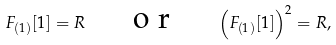<formula> <loc_0><loc_0><loc_500><loc_500>F _ { ( 1 ) } [ 1 ] = R \quad \emph { \emph { o r } } \quad \left ( F _ { ( 1 ) } [ 1 ] \right ) ^ { 2 } = R ,</formula> 